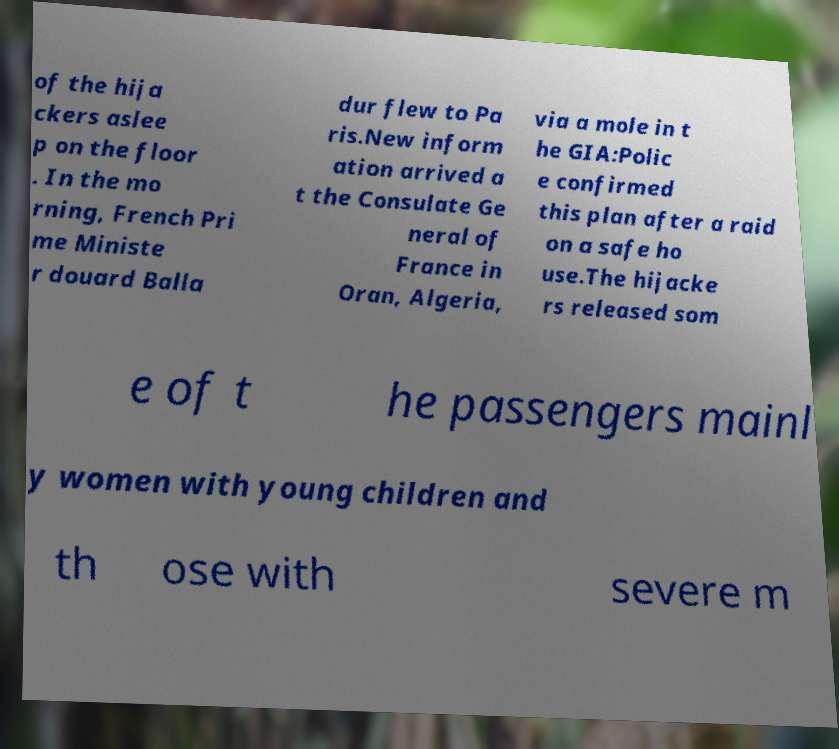Can you accurately transcribe the text from the provided image for me? of the hija ckers aslee p on the floor . In the mo rning, French Pri me Ministe r douard Balla dur flew to Pa ris.New inform ation arrived a t the Consulate Ge neral of France in Oran, Algeria, via a mole in t he GIA:Polic e confirmed this plan after a raid on a safe ho use.The hijacke rs released som e of t he passengers mainl y women with young children and th ose with severe m 